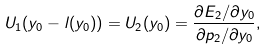Convert formula to latex. <formula><loc_0><loc_0><loc_500><loc_500>U _ { 1 } ( y _ { 0 } - l ( y _ { 0 } ) ) = U _ { 2 } ( y _ { 0 } ) = \frac { \partial E _ { 2 } / \partial y _ { 0 } } { \partial p _ { 2 } / \partial y _ { 0 } } ,</formula> 